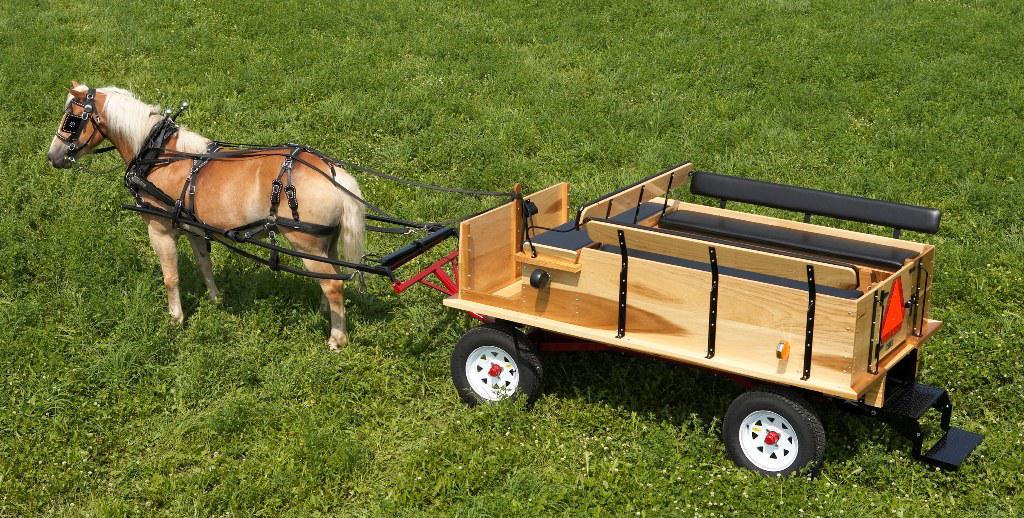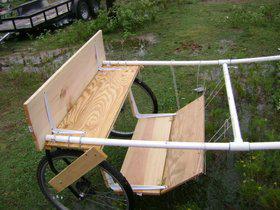The first image is the image on the left, the second image is the image on the right. Analyze the images presented: Is the assertion "There is exactly one horse in the iamge on the left." valid? Answer yes or no. Yes. 